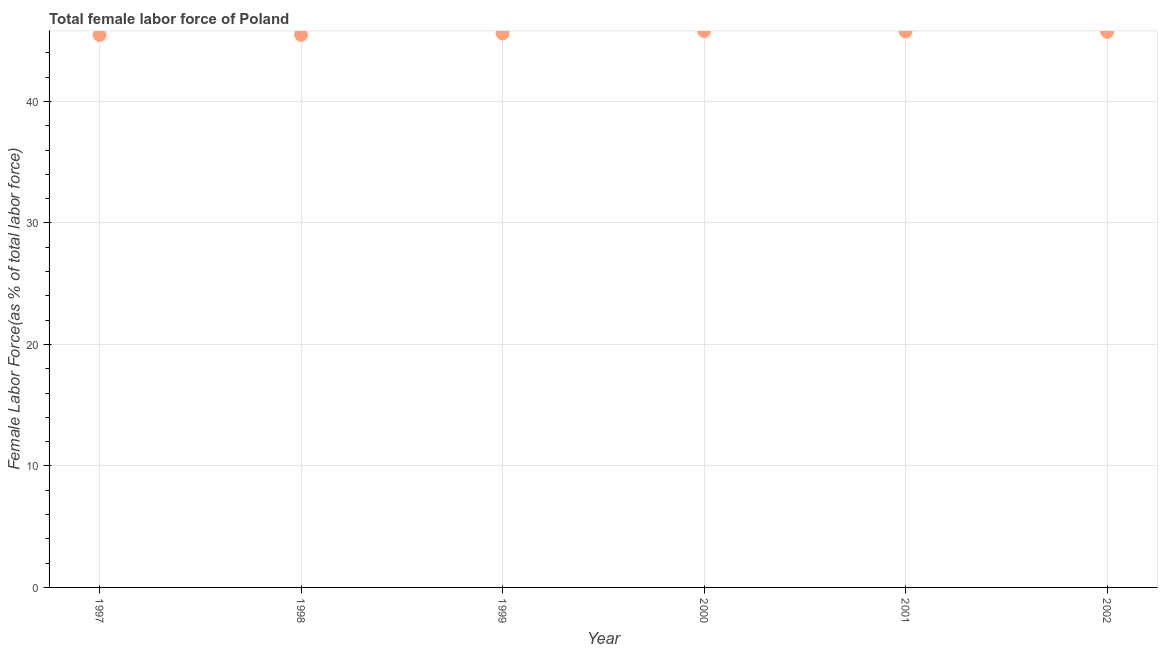What is the total female labor force in 2001?
Offer a very short reply. 45.76. Across all years, what is the maximum total female labor force?
Provide a short and direct response. 45.8. Across all years, what is the minimum total female labor force?
Offer a terse response. 45.47. What is the sum of the total female labor force?
Offer a terse response. 273.84. What is the difference between the total female labor force in 1997 and 1999?
Your answer should be compact. -0.13. What is the average total female labor force per year?
Provide a short and direct response. 45.64. What is the median total female labor force?
Offer a terse response. 45.67. What is the ratio of the total female labor force in 1998 to that in 2001?
Your answer should be compact. 0.99. Is the difference between the total female labor force in 1999 and 2002 greater than the difference between any two years?
Offer a very short reply. No. What is the difference between the highest and the second highest total female labor force?
Your answer should be compact. 0.03. Is the sum of the total female labor force in 1999 and 2001 greater than the maximum total female labor force across all years?
Make the answer very short. Yes. What is the difference between the highest and the lowest total female labor force?
Your answer should be very brief. 0.33. In how many years, is the total female labor force greater than the average total female labor force taken over all years?
Offer a very short reply. 3. How many years are there in the graph?
Ensure brevity in your answer.  6. Does the graph contain any zero values?
Your answer should be very brief. No. Does the graph contain grids?
Offer a terse response. Yes. What is the title of the graph?
Provide a short and direct response. Total female labor force of Poland. What is the label or title of the X-axis?
Give a very brief answer. Year. What is the label or title of the Y-axis?
Your response must be concise. Female Labor Force(as % of total labor force). What is the Female Labor Force(as % of total labor force) in 1997?
Your answer should be very brief. 45.47. What is the Female Labor Force(as % of total labor force) in 1998?
Keep it short and to the point. 45.48. What is the Female Labor Force(as % of total labor force) in 1999?
Offer a very short reply. 45.6. What is the Female Labor Force(as % of total labor force) in 2000?
Offer a terse response. 45.8. What is the Female Labor Force(as % of total labor force) in 2001?
Offer a terse response. 45.76. What is the Female Labor Force(as % of total labor force) in 2002?
Give a very brief answer. 45.73. What is the difference between the Female Labor Force(as % of total labor force) in 1997 and 1998?
Your answer should be compact. -0.01. What is the difference between the Female Labor Force(as % of total labor force) in 1997 and 1999?
Provide a succinct answer. -0.13. What is the difference between the Female Labor Force(as % of total labor force) in 1997 and 2000?
Provide a succinct answer. -0.33. What is the difference between the Female Labor Force(as % of total labor force) in 1997 and 2001?
Offer a very short reply. -0.3. What is the difference between the Female Labor Force(as % of total labor force) in 1997 and 2002?
Provide a succinct answer. -0.26. What is the difference between the Female Labor Force(as % of total labor force) in 1998 and 1999?
Keep it short and to the point. -0.12. What is the difference between the Female Labor Force(as % of total labor force) in 1998 and 2000?
Provide a short and direct response. -0.31. What is the difference between the Female Labor Force(as % of total labor force) in 1998 and 2001?
Your response must be concise. -0.28. What is the difference between the Female Labor Force(as % of total labor force) in 1998 and 2002?
Ensure brevity in your answer.  -0.25. What is the difference between the Female Labor Force(as % of total labor force) in 1999 and 2000?
Your response must be concise. -0.2. What is the difference between the Female Labor Force(as % of total labor force) in 1999 and 2001?
Provide a succinct answer. -0.17. What is the difference between the Female Labor Force(as % of total labor force) in 1999 and 2002?
Ensure brevity in your answer.  -0.13. What is the difference between the Female Labor Force(as % of total labor force) in 2000 and 2001?
Provide a succinct answer. 0.03. What is the difference between the Female Labor Force(as % of total labor force) in 2000 and 2002?
Provide a short and direct response. 0.06. What is the difference between the Female Labor Force(as % of total labor force) in 2001 and 2002?
Make the answer very short. 0.03. What is the ratio of the Female Labor Force(as % of total labor force) in 1997 to that in 1998?
Your answer should be compact. 1. What is the ratio of the Female Labor Force(as % of total labor force) in 1997 to that in 2000?
Your response must be concise. 0.99. What is the ratio of the Female Labor Force(as % of total labor force) in 1997 to that in 2001?
Ensure brevity in your answer.  0.99. What is the ratio of the Female Labor Force(as % of total labor force) in 1997 to that in 2002?
Your answer should be compact. 0.99. What is the ratio of the Female Labor Force(as % of total labor force) in 1998 to that in 2001?
Offer a terse response. 0.99. What is the ratio of the Female Labor Force(as % of total labor force) in 1999 to that in 2000?
Provide a succinct answer. 1. What is the ratio of the Female Labor Force(as % of total labor force) in 1999 to that in 2001?
Give a very brief answer. 1. What is the ratio of the Female Labor Force(as % of total labor force) in 2000 to that in 2001?
Provide a short and direct response. 1. What is the ratio of the Female Labor Force(as % of total labor force) in 2000 to that in 2002?
Provide a succinct answer. 1. What is the ratio of the Female Labor Force(as % of total labor force) in 2001 to that in 2002?
Provide a short and direct response. 1. 